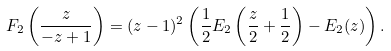Convert formula to latex. <formula><loc_0><loc_0><loc_500><loc_500>F _ { 2 } \left ( \frac { z } { - z + 1 } \right ) & = ( z - 1 ) ^ { 2 } \left ( \frac { 1 } { 2 } E _ { 2 } \left ( \frac { z } { 2 } + \frac { 1 } { 2 } \right ) - E _ { 2 } ( z ) \right ) .</formula> 